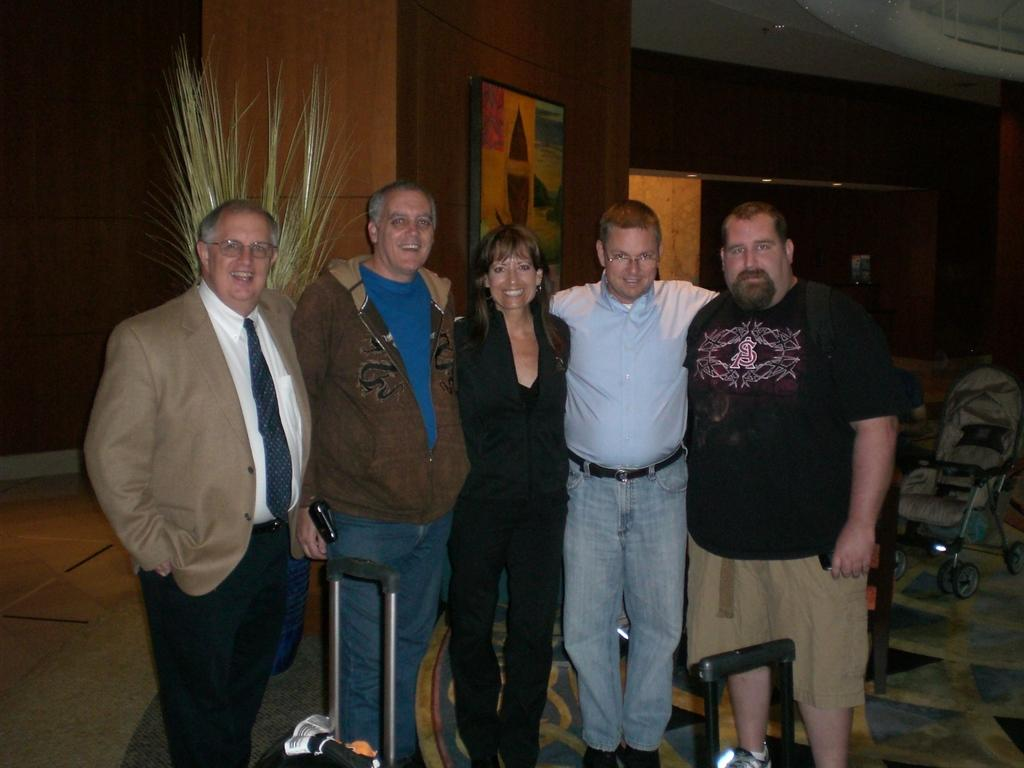How many people are in the image? There are five people in the image, including four men and one woman. What are the people in the image doing? The people are standing. What objects are in front of the people? There are two suitcases in front of the people. What can be seen in the background of the image? There is a baby stroller in the background of the image. What type of sack is being used to carry the mail in the image? There is no sack or mail present in the image. How many shoes are visible on the people in the image? The image does not show the shoes of the people, so it cannot be determined how many shoes are visible. 